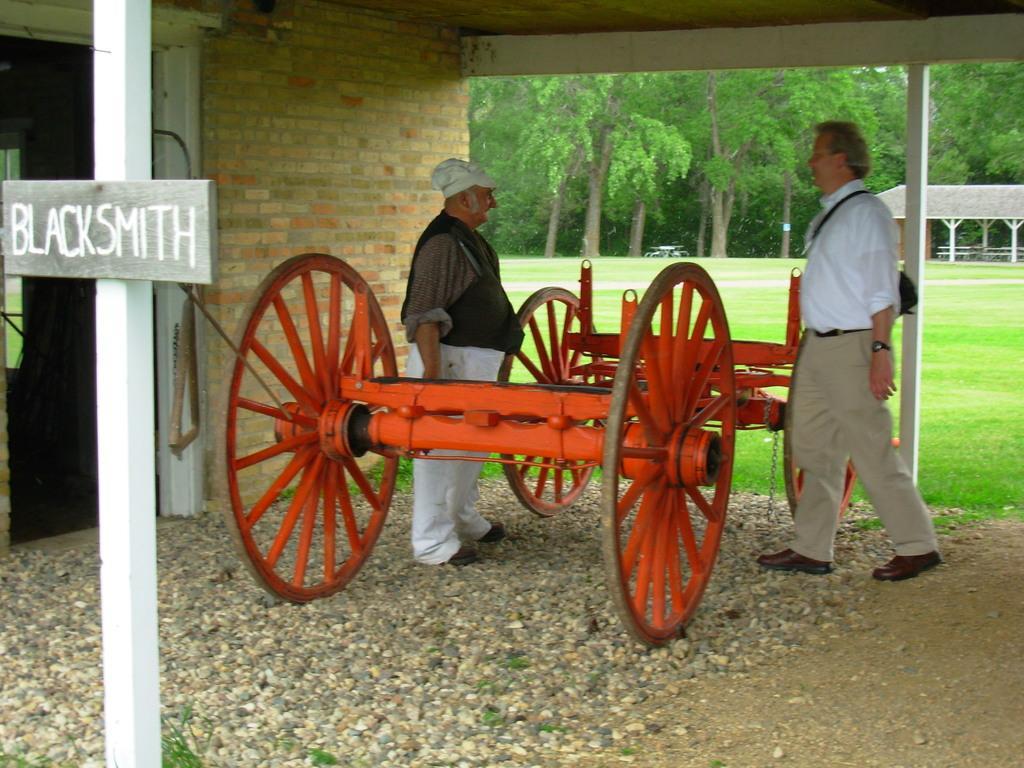How would you summarize this image in a sentence or two? In this picture we can see two wheel carts and two people standing. We can see some grass and stones on the ground. There is a text visible on a board. We can see a brick wall, trees, an object and a shed in the background. 